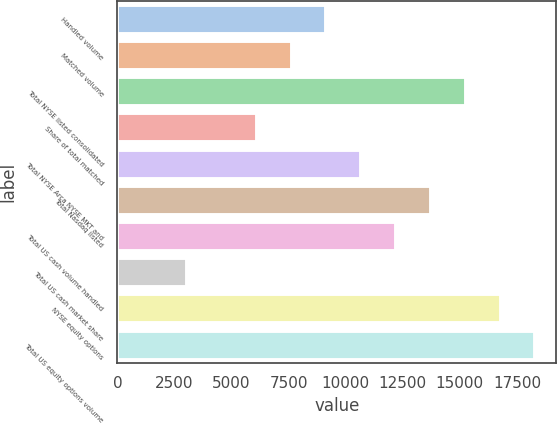<chart> <loc_0><loc_0><loc_500><loc_500><bar_chart><fcel>Handled volume<fcel>Matched volume<fcel>Total NYSE listed consolidated<fcel>Share of total matched<fcel>Total NYSE Arca NYSE MKT and<fcel>Total Nasdaq listed<fcel>Total US cash volume handled<fcel>Total US cash market share<fcel>NYSE equity options<fcel>Total US equity options volume<nl><fcel>9154.82<fcel>7629.02<fcel>15258<fcel>6103.23<fcel>10680.6<fcel>13732.2<fcel>12206.4<fcel>3051.64<fcel>16783.8<fcel>18309.6<nl></chart> 